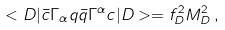<formula> <loc_0><loc_0><loc_500><loc_500>< D | \bar { c } \Gamma _ { \alpha } q \bar { q } \Gamma ^ { \alpha } c | D > = f ^ { 2 } _ { D } M ^ { 2 } _ { D } \, ,</formula> 